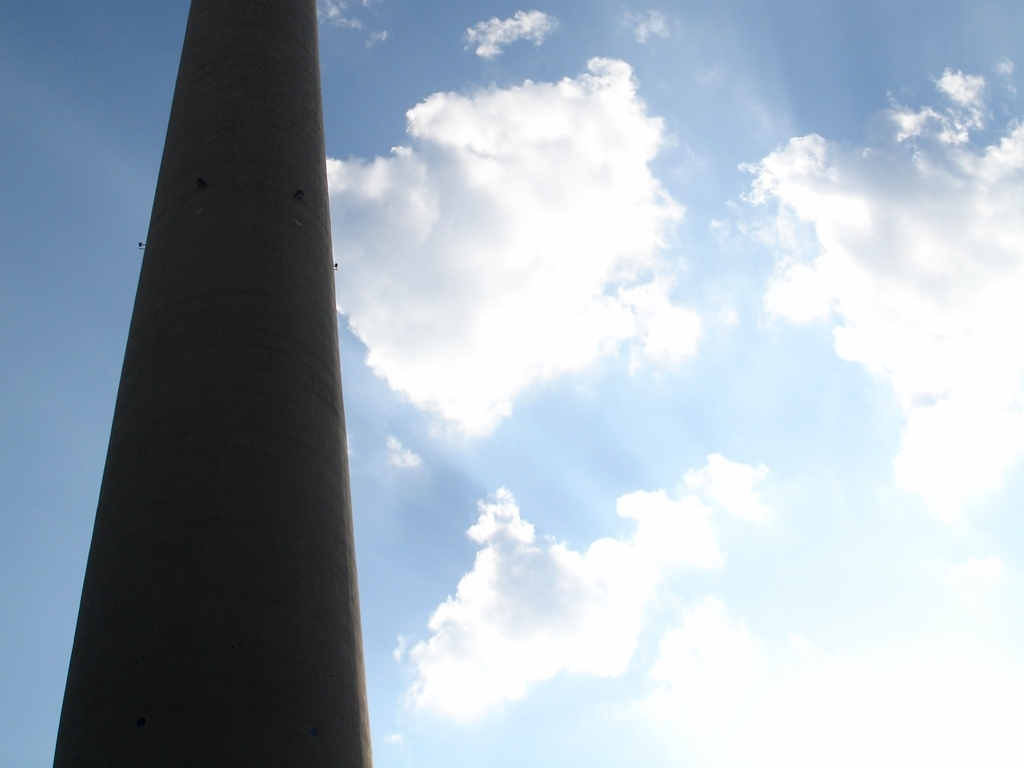Could you describe the weather conditions depicted in this image? It appears to be a day with clear weather where the sky is mostly bright with scattered clouds. These cumulus clouds are well-defined with sharp edges, indicating a relatively calm weather pattern with no immediate signs of precipitation. How can you tell the clouds are cumulus? Cumulus clouds are characterized by their fluffy, cotton-like appearance and well-defined edges, as seen in the photo. They form when warm air rises and cools, condensing into these distinctive shapes. Their presence often indicates good weather. 